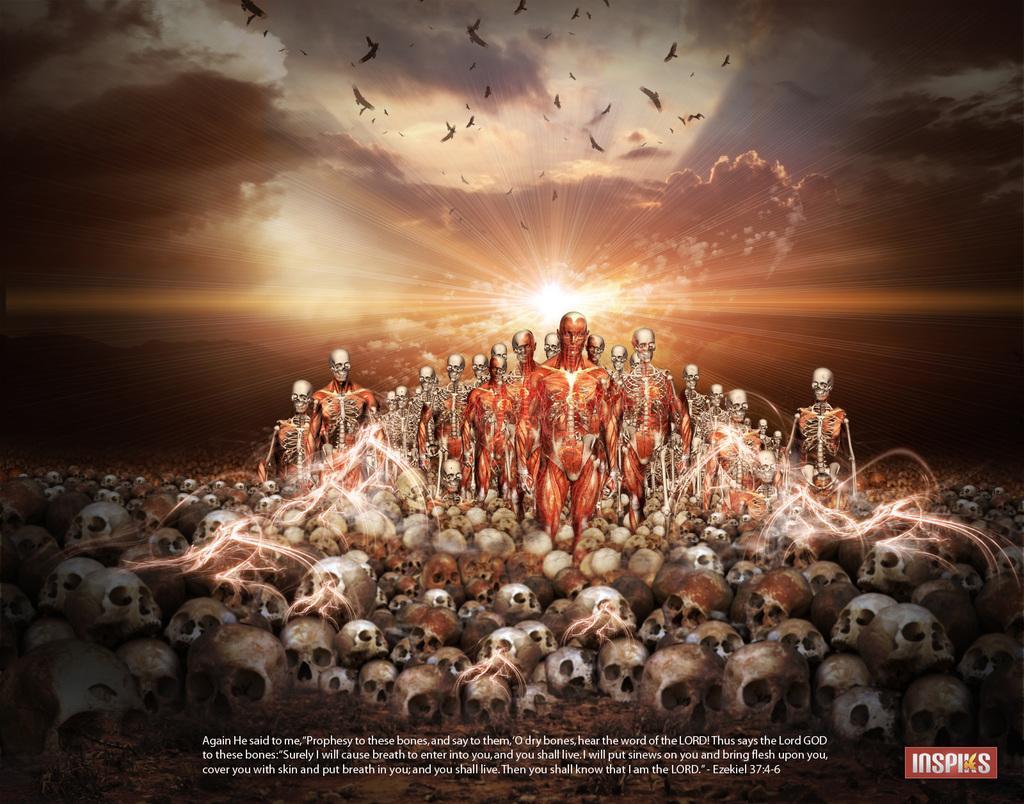In one or two sentences, can you explain what this image depicts? At the bottom of the image there are many skulls. In between the skulls there are many skeletons and also there are few skeletons with muscles. At the top of the image there is a sky with clouds and sunlight and also there are birds. 